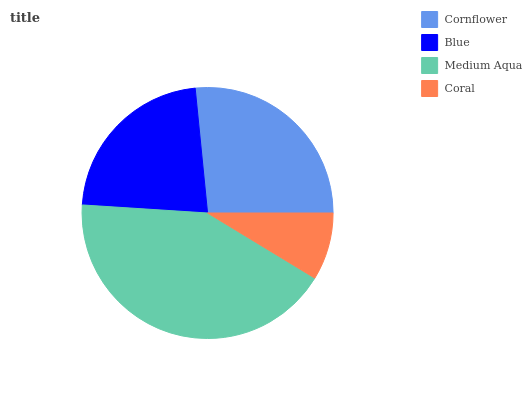Is Coral the minimum?
Answer yes or no. Yes. Is Medium Aqua the maximum?
Answer yes or no. Yes. Is Blue the minimum?
Answer yes or no. No. Is Blue the maximum?
Answer yes or no. No. Is Cornflower greater than Blue?
Answer yes or no. Yes. Is Blue less than Cornflower?
Answer yes or no. Yes. Is Blue greater than Cornflower?
Answer yes or no. No. Is Cornflower less than Blue?
Answer yes or no. No. Is Cornflower the high median?
Answer yes or no. Yes. Is Blue the low median?
Answer yes or no. Yes. Is Coral the high median?
Answer yes or no. No. Is Coral the low median?
Answer yes or no. No. 